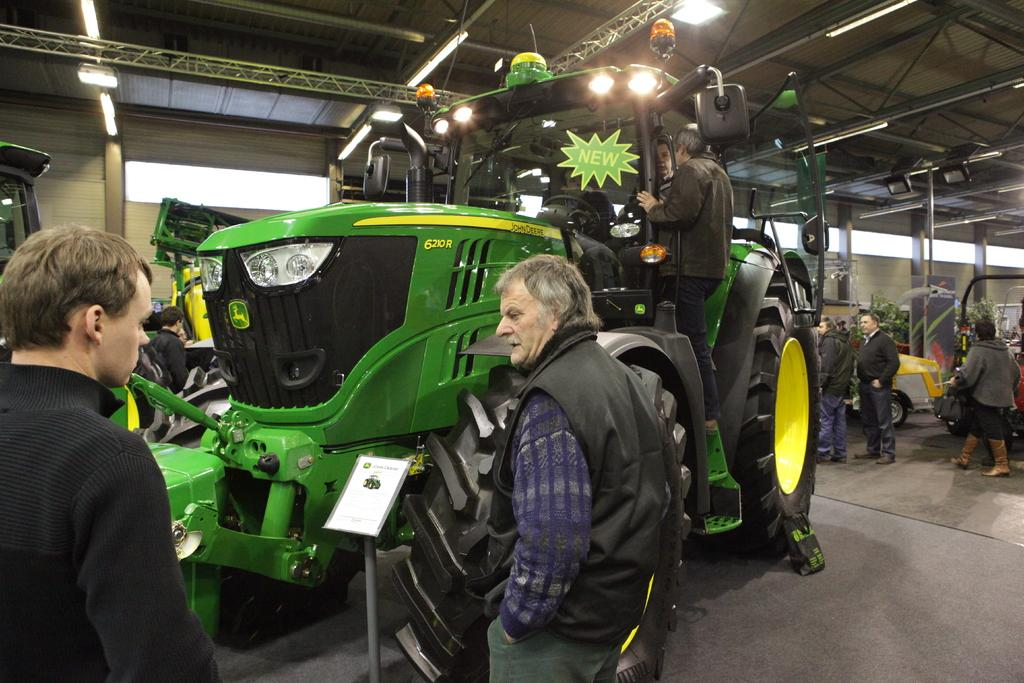What types of objects are present in the image? There are vehicles, people, and objects in the image. What are the people on the floor doing? Some people are standing with a paper on the floor. What can be seen in the background of the image? There is a wall visible in the background of the image. What type of wood can be seen in the image? There is no wood present in the image. Are there any sails visible in the image? There are no sails present in the image. 